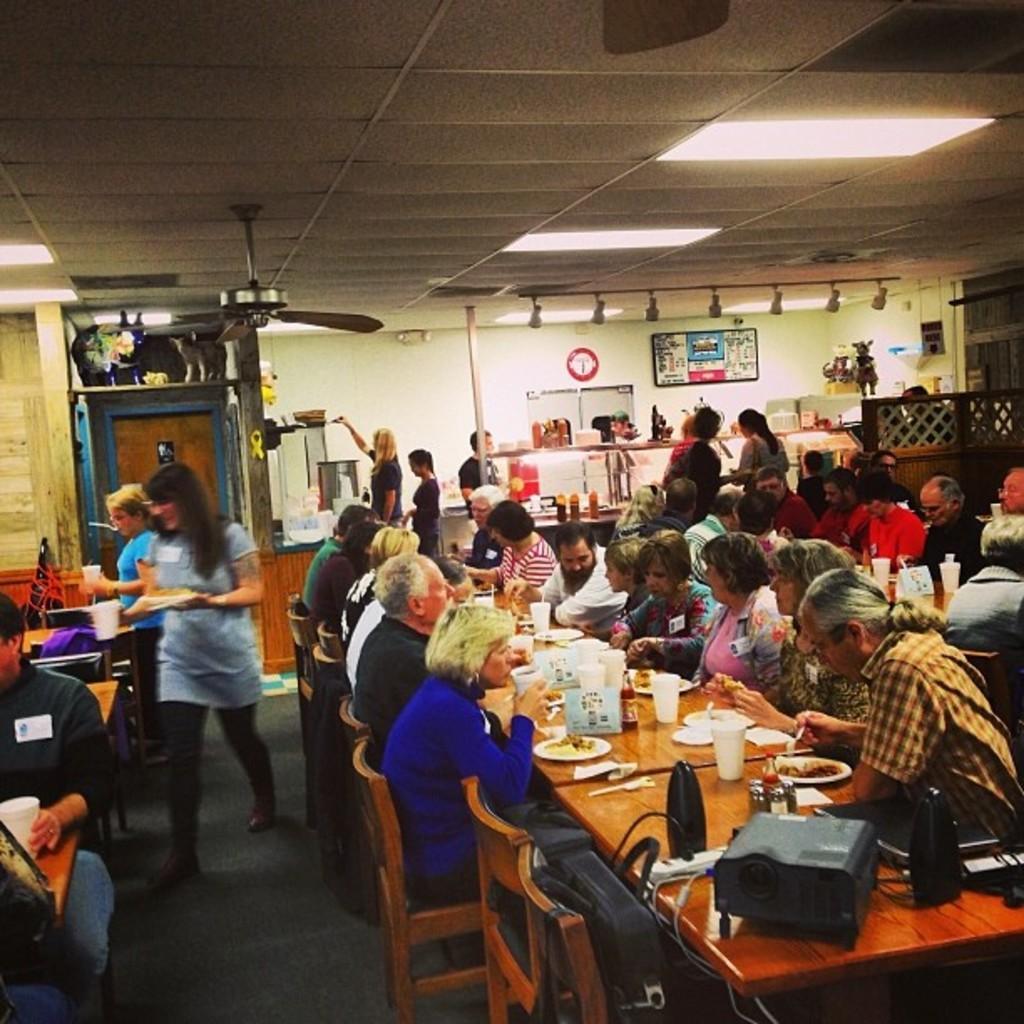Please provide a concise description of this image. In this picture we can see some people sitting on chairs in front of tables, there are glasses, cups, plates, spoons, tissue papers, bottles present on theses tables, in the background there is a wall and a screen, we can see some people standing, there is a door on the left side, we can see lights, a fan and the ceiling at the top of the picture, we can see a clock on the wall. 